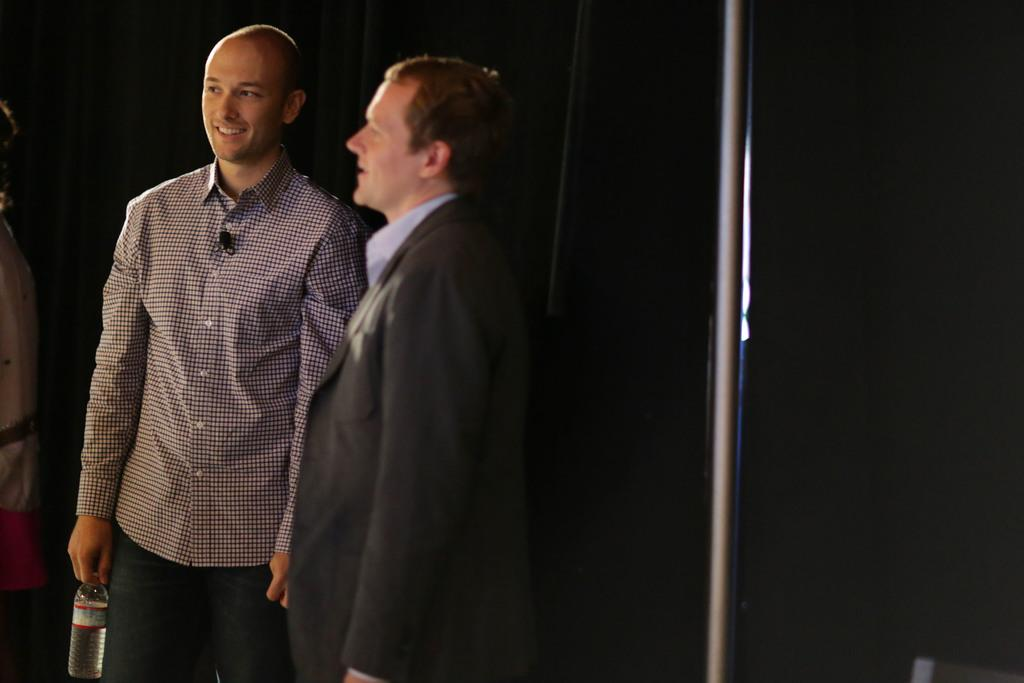How many people are on the left side of the image? There are two persons on the left side of the image. What are the expressions on their faces? Both persons are smiling. What is one of the persons holding? One of the persons is holding a bottle. What can be seen on the right side of the image? There is a pole on the right side of the image. What is the color of the background in the image? The background of the image is dark in color. Can you see a sofa in the image? No, there is no sofa present in the image. Are the two persons kissing in the image? No, the two persons are not kissing in the image; they are both smiling. 